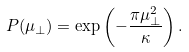<formula> <loc_0><loc_0><loc_500><loc_500>P ( \mu _ { \perp } ) = \exp \left ( - \frac { \pi \mu _ { \perp } ^ { 2 } } { \kappa } \right ) .</formula> 